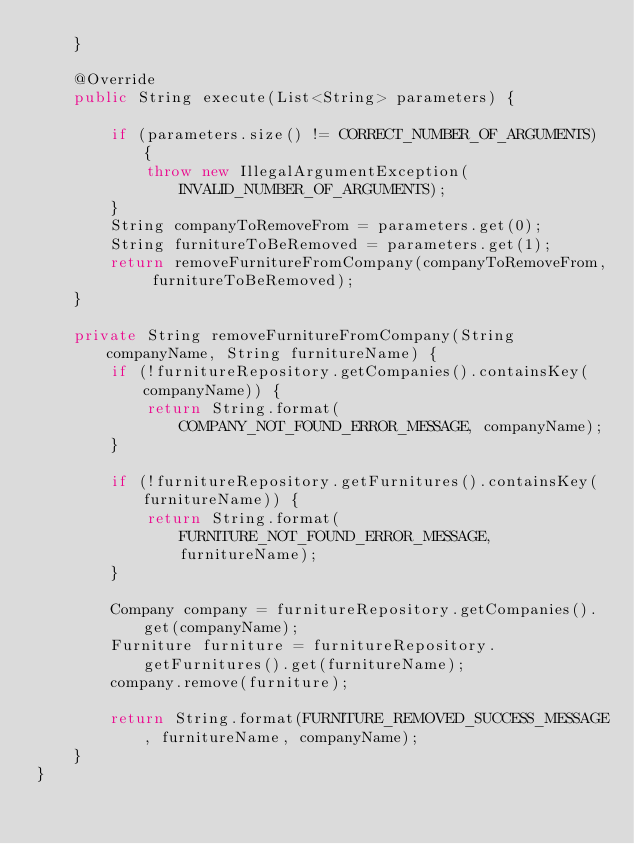<code> <loc_0><loc_0><loc_500><loc_500><_Java_>    }

    @Override
    public String execute(List<String> parameters) {

        if (parameters.size() != CORRECT_NUMBER_OF_ARGUMENTS) {
            throw new IllegalArgumentException(INVALID_NUMBER_OF_ARGUMENTS);
        }
        String companyToRemoveFrom = parameters.get(0);
        String furnitureToBeRemoved = parameters.get(1);
        return removeFurnitureFromCompany(companyToRemoveFrom, furnitureToBeRemoved);
    }

    private String removeFurnitureFromCompany(String companyName, String furnitureName) {
        if (!furnitureRepository.getCompanies().containsKey(companyName)) {
            return String.format(COMPANY_NOT_FOUND_ERROR_MESSAGE, companyName);
        }

        if (!furnitureRepository.getFurnitures().containsKey(furnitureName)) {
            return String.format(FURNITURE_NOT_FOUND_ERROR_MESSAGE, furnitureName);
        }

        Company company = furnitureRepository.getCompanies().get(companyName);
        Furniture furniture = furnitureRepository.getFurnitures().get(furnitureName);
        company.remove(furniture);

        return String.format(FURNITURE_REMOVED_SUCCESS_MESSAGE, furnitureName, companyName);
    }
}
</code> 